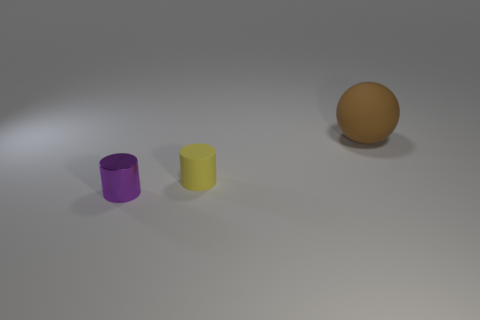Judging by the shadows, where would you say the light source is located in relation to the objects? The light source appears to be coming from the upper left side of the frame because the shadows are cast towards the lower right. If I wanted to set up a similar scene, what type of light should I use to achieve this shadow effect? You should use a diffused light source positioned to the left and slightly above the objects' height. This will provide even lighting with soft-edged shadows, similar to what's depicted in the image. 